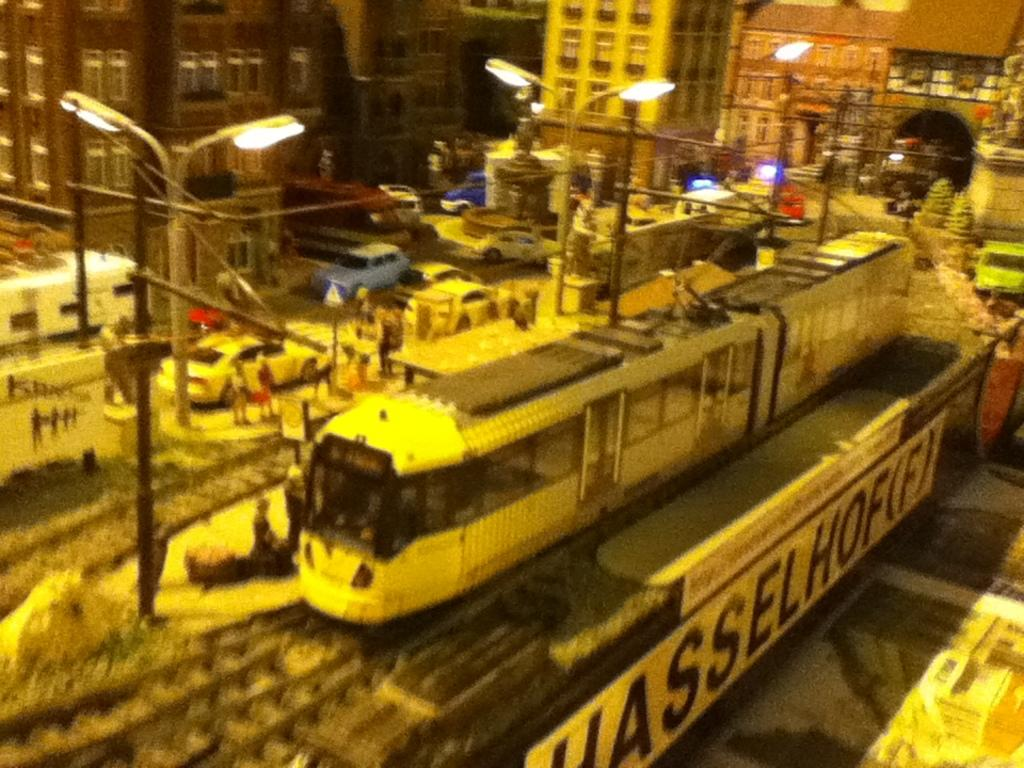<image>
Summarize the visual content of the image. A train is on the racks with a sign about Hasselhofifi beneath it. 